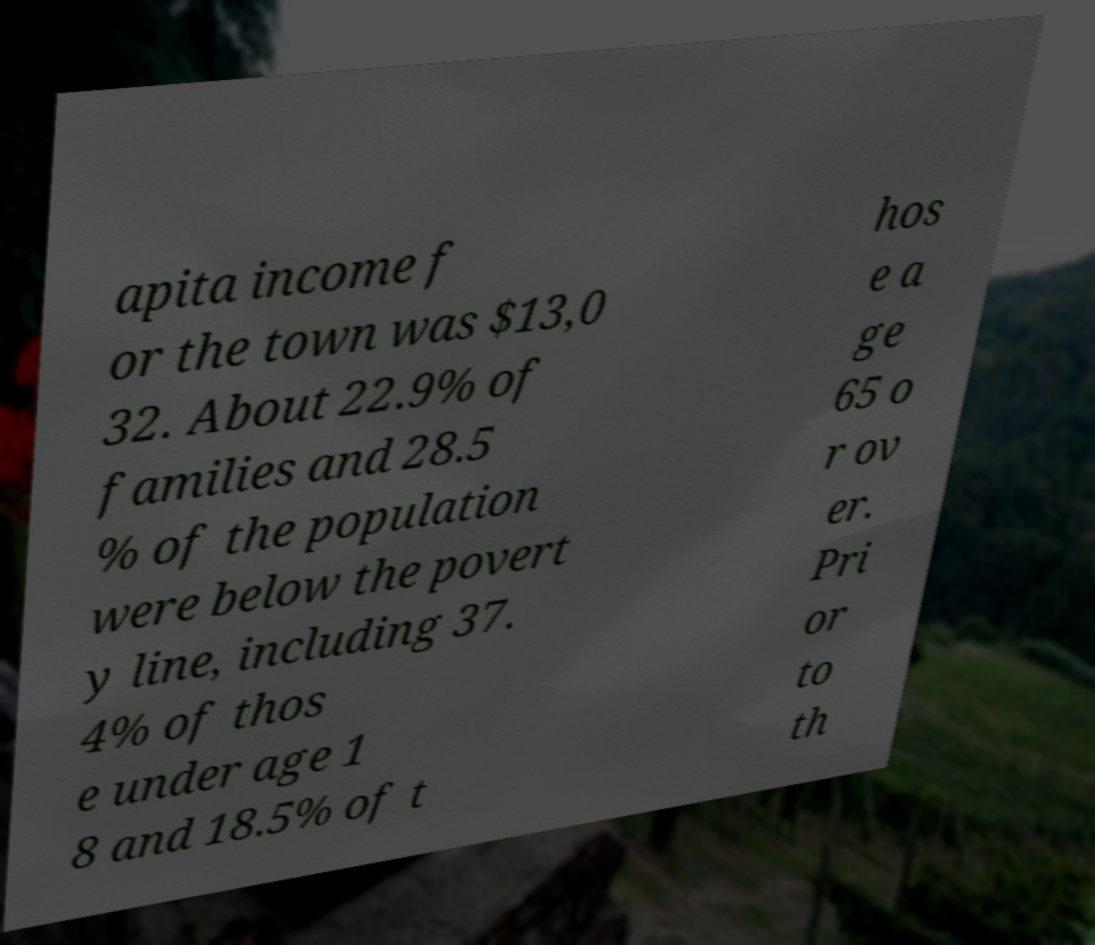Please identify and transcribe the text found in this image. apita income f or the town was $13,0 32. About 22.9% of families and 28.5 % of the population were below the povert y line, including 37. 4% of thos e under age 1 8 and 18.5% of t hos e a ge 65 o r ov er. Pri or to th 